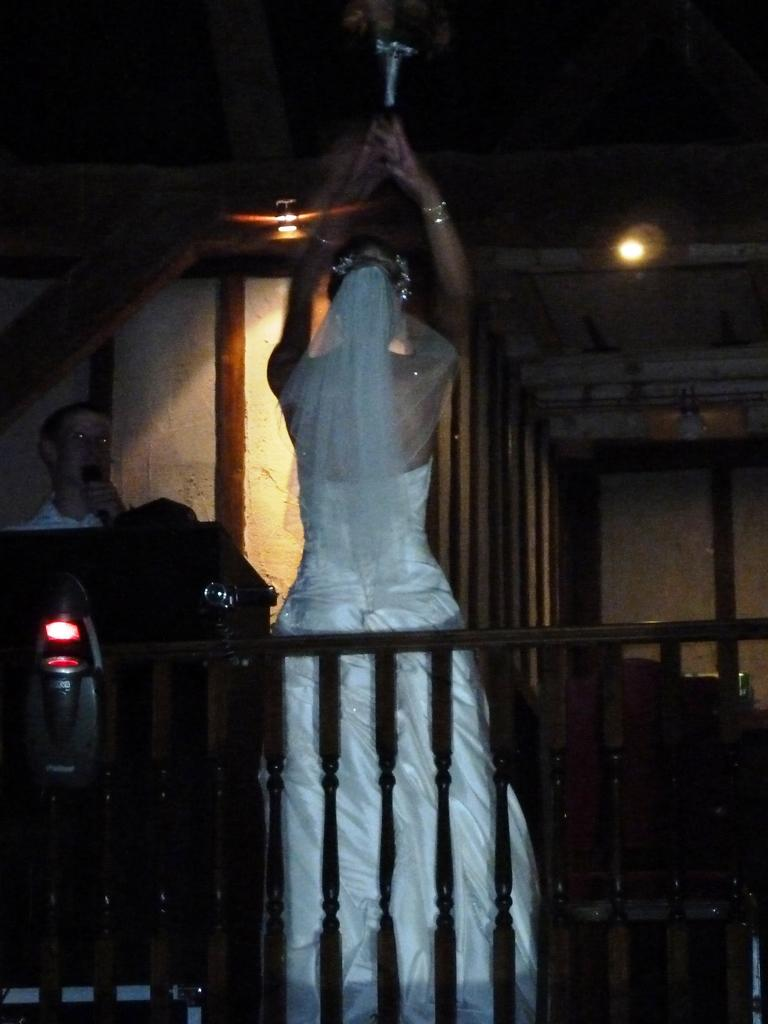What is the main subject in the middle of the room in the image? There is a bride standing in the middle of the room in the image. What is the man in the image doing? The man is speaking into a microphone in the image. What type of support can be seen in the image for the bride to lean on? There is no visible support for the bride to lean on in the image. What color is the silver camp in the image? There is no camp or silver object present in the image. 